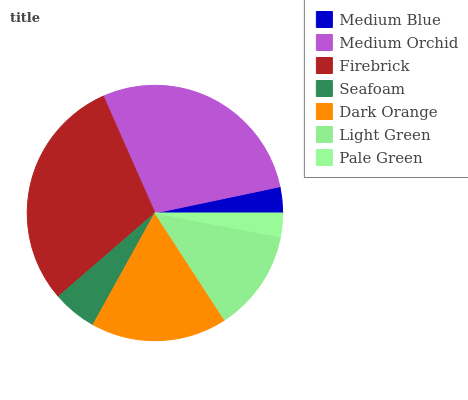Is Pale Green the minimum?
Answer yes or no. Yes. Is Firebrick the maximum?
Answer yes or no. Yes. Is Medium Orchid the minimum?
Answer yes or no. No. Is Medium Orchid the maximum?
Answer yes or no. No. Is Medium Orchid greater than Medium Blue?
Answer yes or no. Yes. Is Medium Blue less than Medium Orchid?
Answer yes or no. Yes. Is Medium Blue greater than Medium Orchid?
Answer yes or no. No. Is Medium Orchid less than Medium Blue?
Answer yes or no. No. Is Light Green the high median?
Answer yes or no. Yes. Is Light Green the low median?
Answer yes or no. Yes. Is Pale Green the high median?
Answer yes or no. No. Is Pale Green the low median?
Answer yes or no. No. 